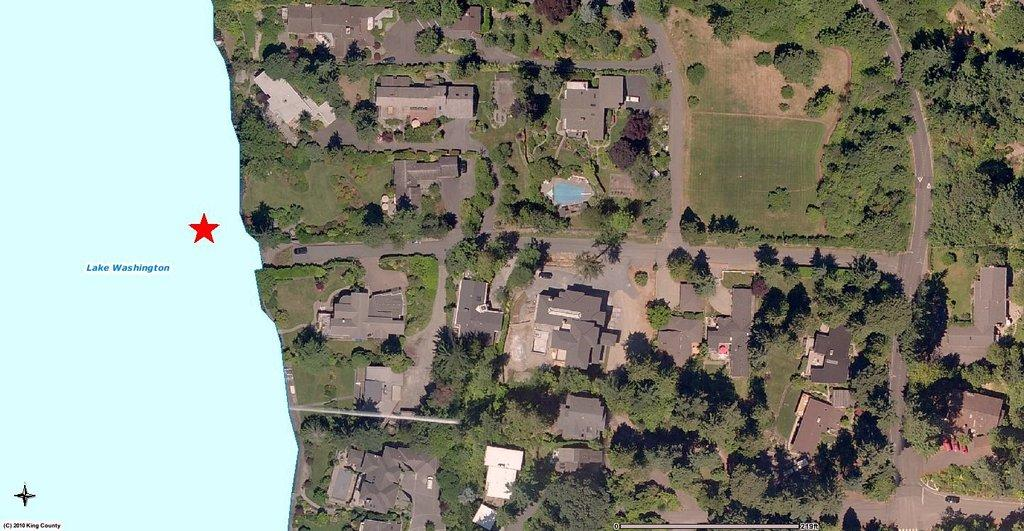What type of view is shown in the image? The image is an aerial view. What structures can be seen in the image? There are buildings in the image. What type of vegetation is present in the image? There are trees and grass in the image. What man-made features are visible in the image? There are roads in the image. What natural feature is on the left side of the image? There is a lake on the left side of the image. What additional information is provided at the bottom left of the image? There is some text at the left bottom of the image. How many oranges are hanging from the trees in the image? There are no oranges visible in the image; it features trees without any fruit. Who is the manager of the buildings shown in the image? The image does not provide any information about the management of the buildings, so it cannot be determined from the image. 